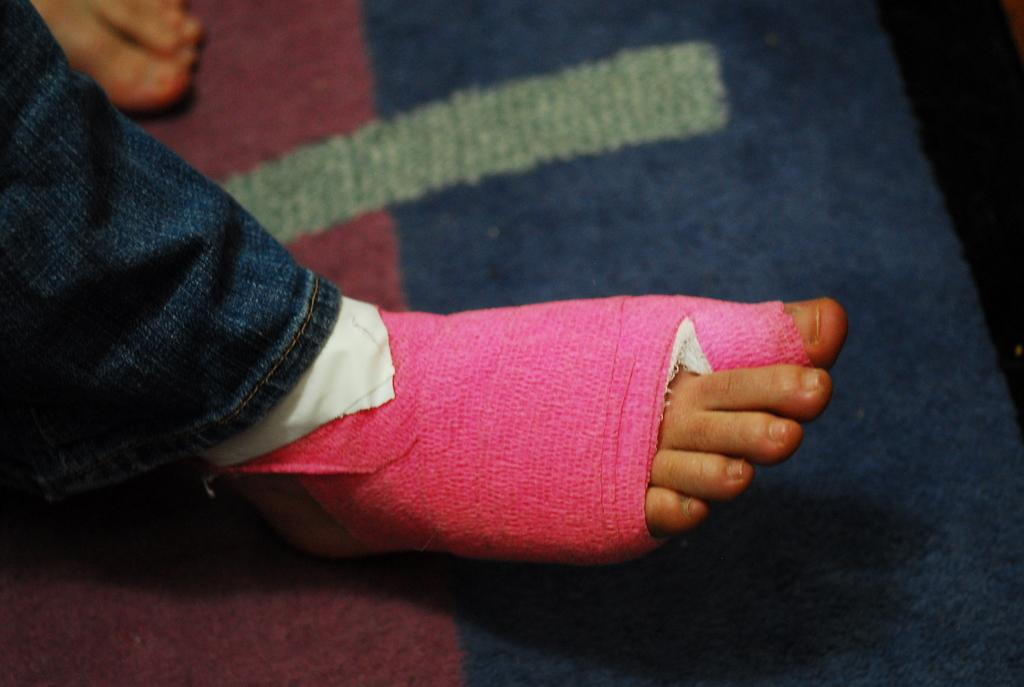What part of a person can be seen in the image? There is a leg of a person in the image. Is there anything unusual about the leg in the image? Yes, there is a bandage on the leg. What type of behavior does the pig exhibit in the image? There is no pig present in the image, so it is not possible to determine its behavior. 